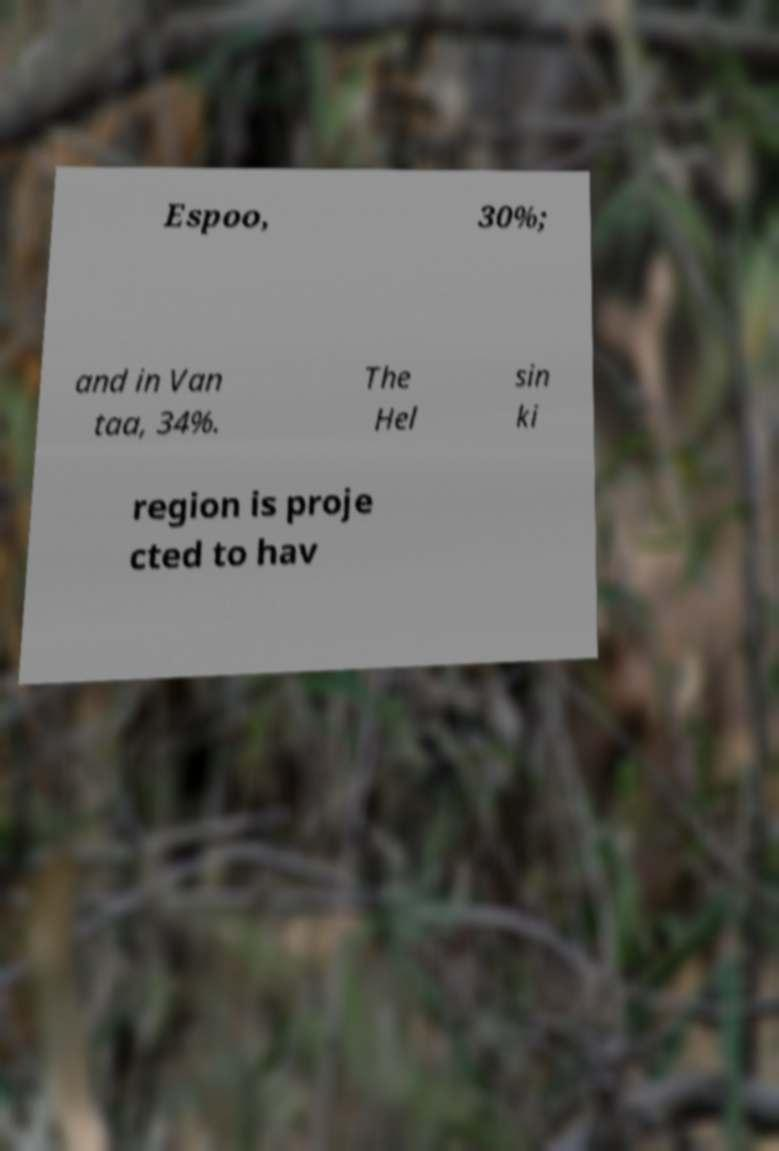Could you extract and type out the text from this image? Espoo, 30%; and in Van taa, 34%. The Hel sin ki region is proje cted to hav 